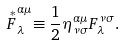Convert formula to latex. <formula><loc_0><loc_0><loc_500><loc_500>\stackrel { * } { F } _ { \lambda } ^ { \alpha \mu } \equiv \frac { 1 } { 2 } \eta _ { \nu \sigma } ^ { \alpha \mu } F _ { \lambda } ^ { \nu \sigma } .</formula> 